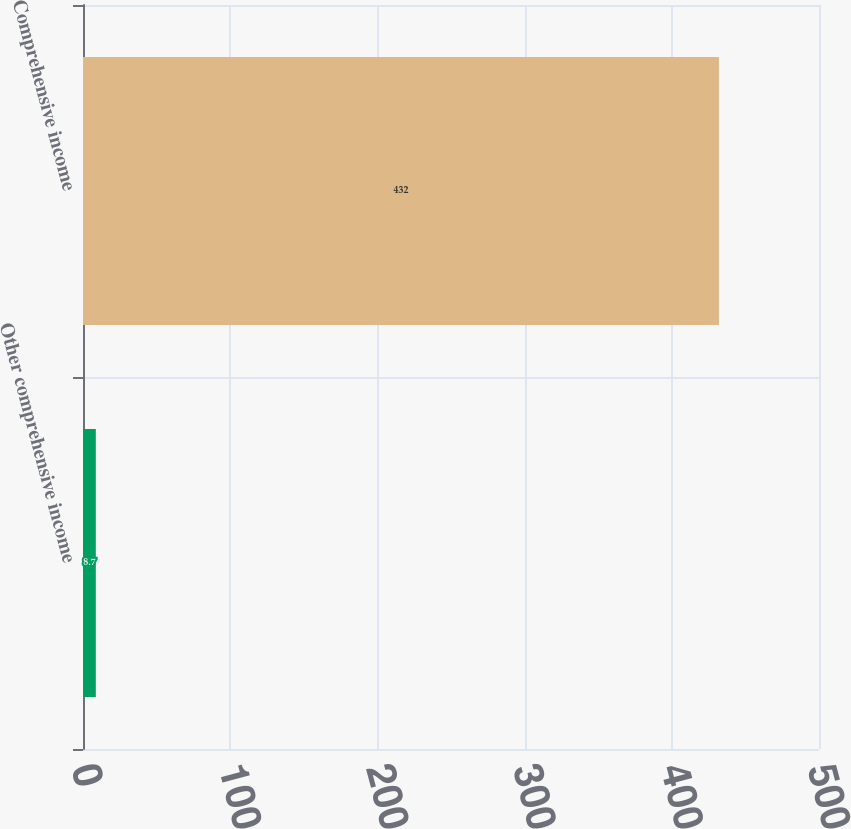<chart> <loc_0><loc_0><loc_500><loc_500><bar_chart><fcel>Other comprehensive income<fcel>Comprehensive income<nl><fcel>8.7<fcel>432<nl></chart> 